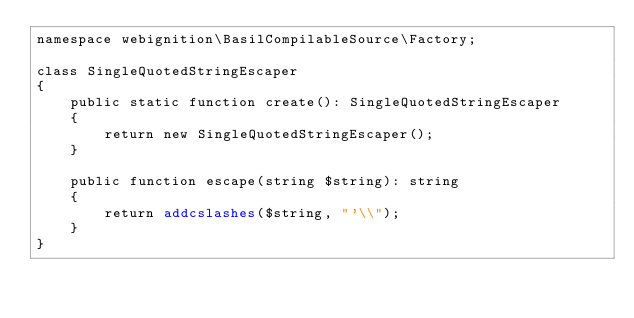Convert code to text. <code><loc_0><loc_0><loc_500><loc_500><_PHP_>namespace webignition\BasilCompilableSource\Factory;

class SingleQuotedStringEscaper
{
    public static function create(): SingleQuotedStringEscaper
    {
        return new SingleQuotedStringEscaper();
    }

    public function escape(string $string): string
    {
        return addcslashes($string, "'\\");
    }
}
</code> 